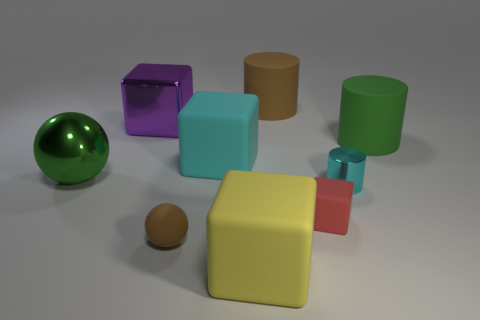Add 1 tiny blue rubber cubes. How many objects exist? 10 Subtract all cylinders. How many objects are left? 6 Subtract 0 cyan spheres. How many objects are left? 9 Subtract all big yellow rubber things. Subtract all purple metallic things. How many objects are left? 7 Add 5 small red matte objects. How many small red matte objects are left? 6 Add 6 tiny brown matte cylinders. How many tiny brown matte cylinders exist? 6 